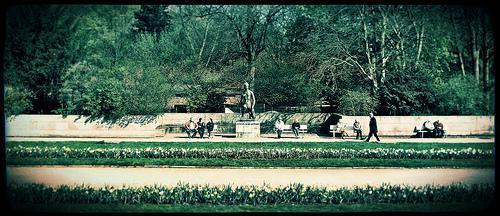How many large stone statues are there?
Give a very brief answer. 1. 